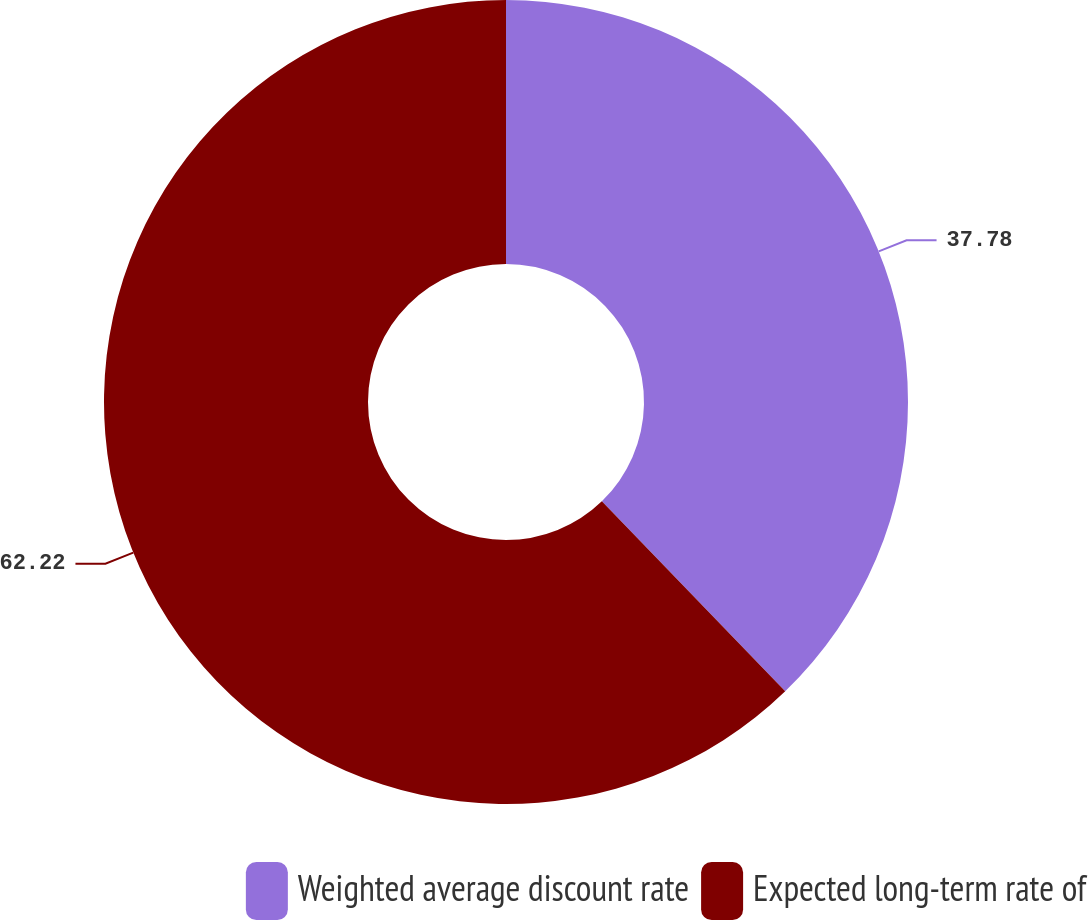Convert chart. <chart><loc_0><loc_0><loc_500><loc_500><pie_chart><fcel>Weighted average discount rate<fcel>Expected long-term rate of<nl><fcel>37.78%<fcel>62.22%<nl></chart> 